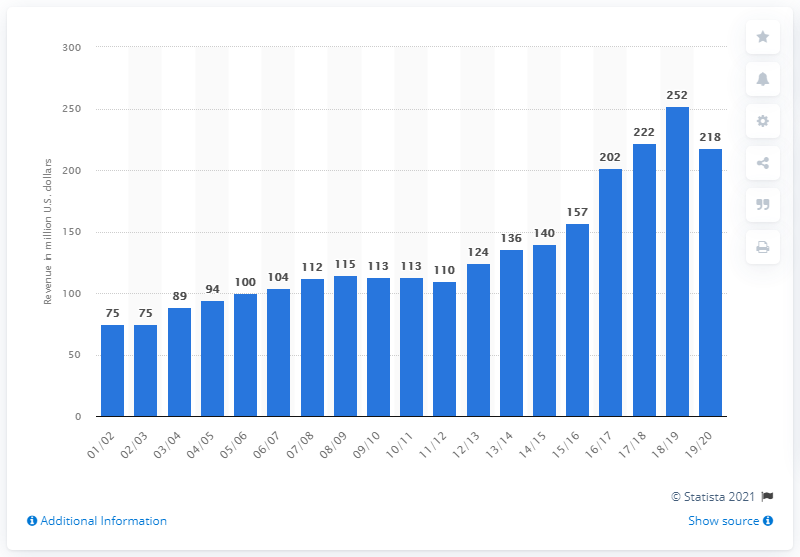Indicate a few pertinent items in this graphic. Based on available data, the Denver Nuggets are projected to generate an estimated revenue of approximately 218 million US dollars in the 2019/2020 season. 